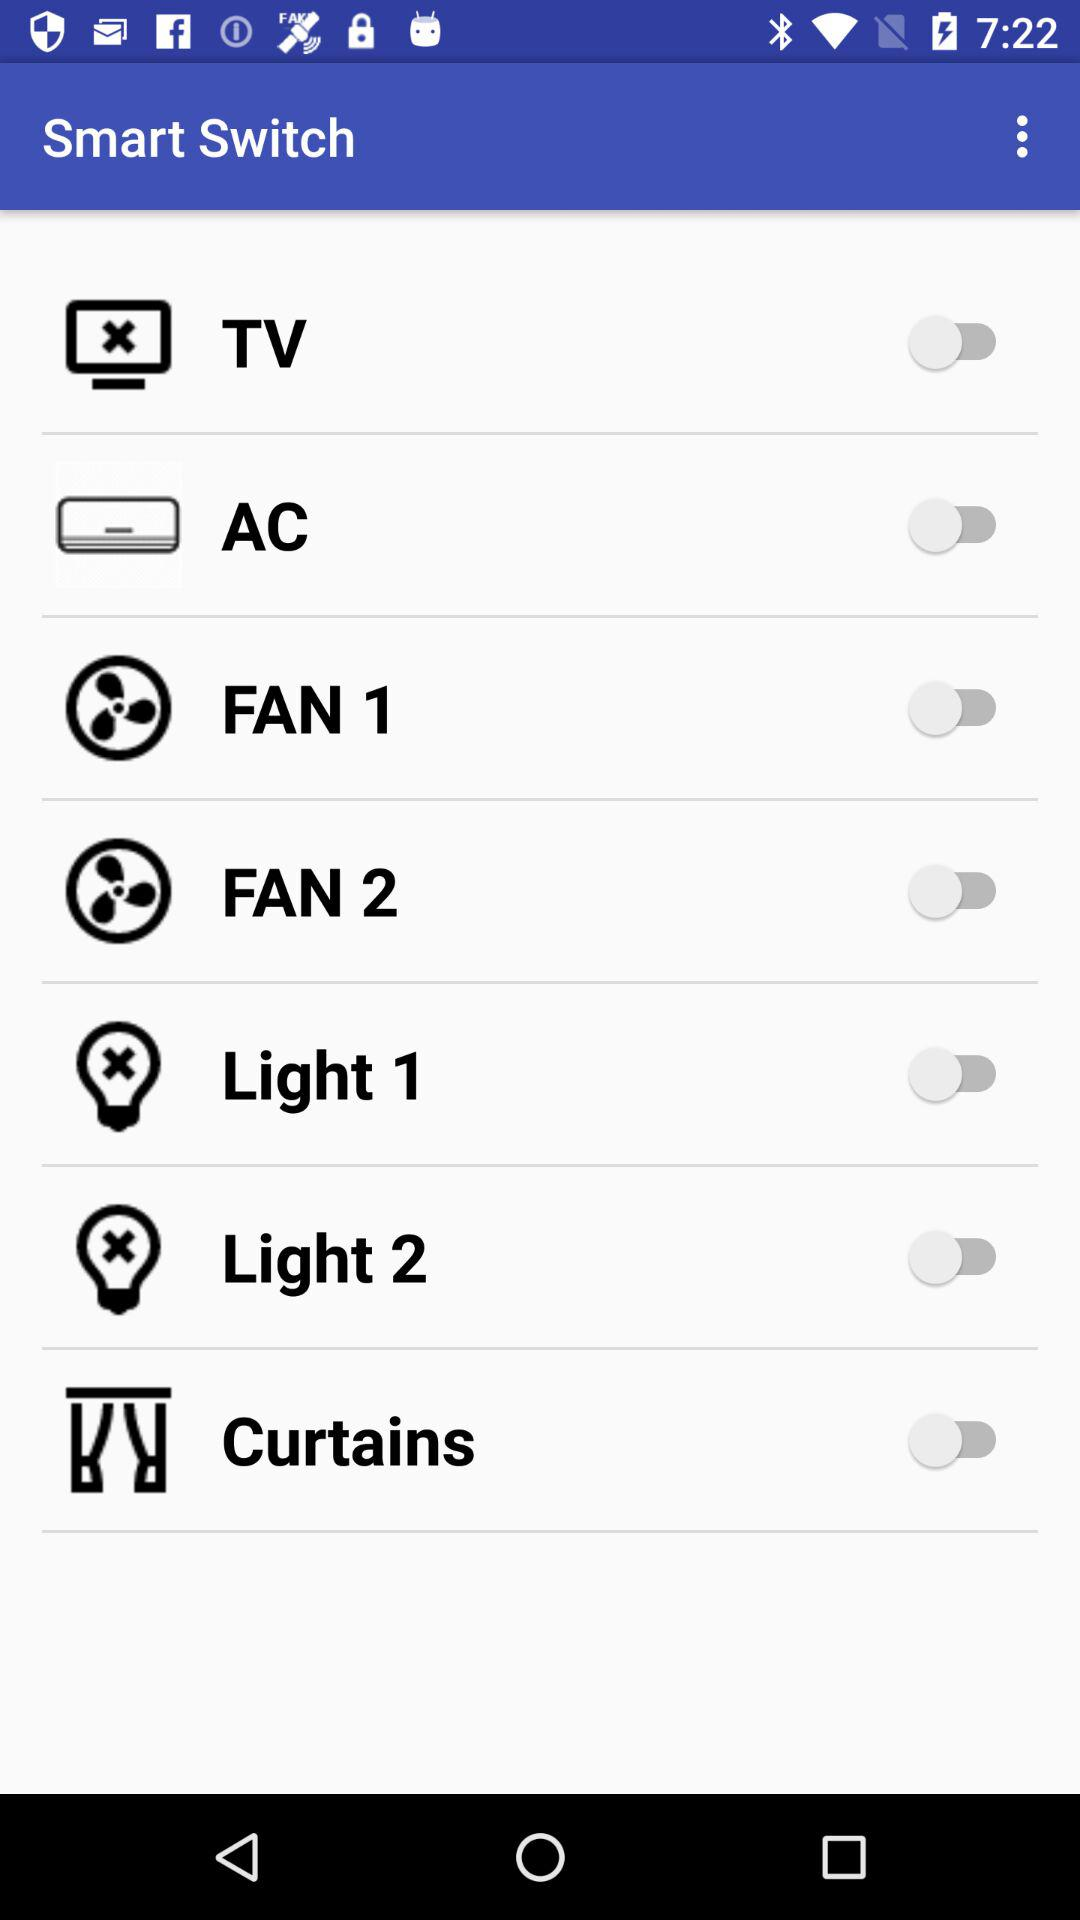What is the status of "TV"? The status of "TV" is "off". 